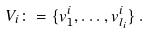Convert formula to latex. <formula><loc_0><loc_0><loc_500><loc_500>V _ { i } \colon = \{ v _ { 1 } ^ { i } , \dots , v _ { l _ { i } } ^ { i } \} \, .</formula> 